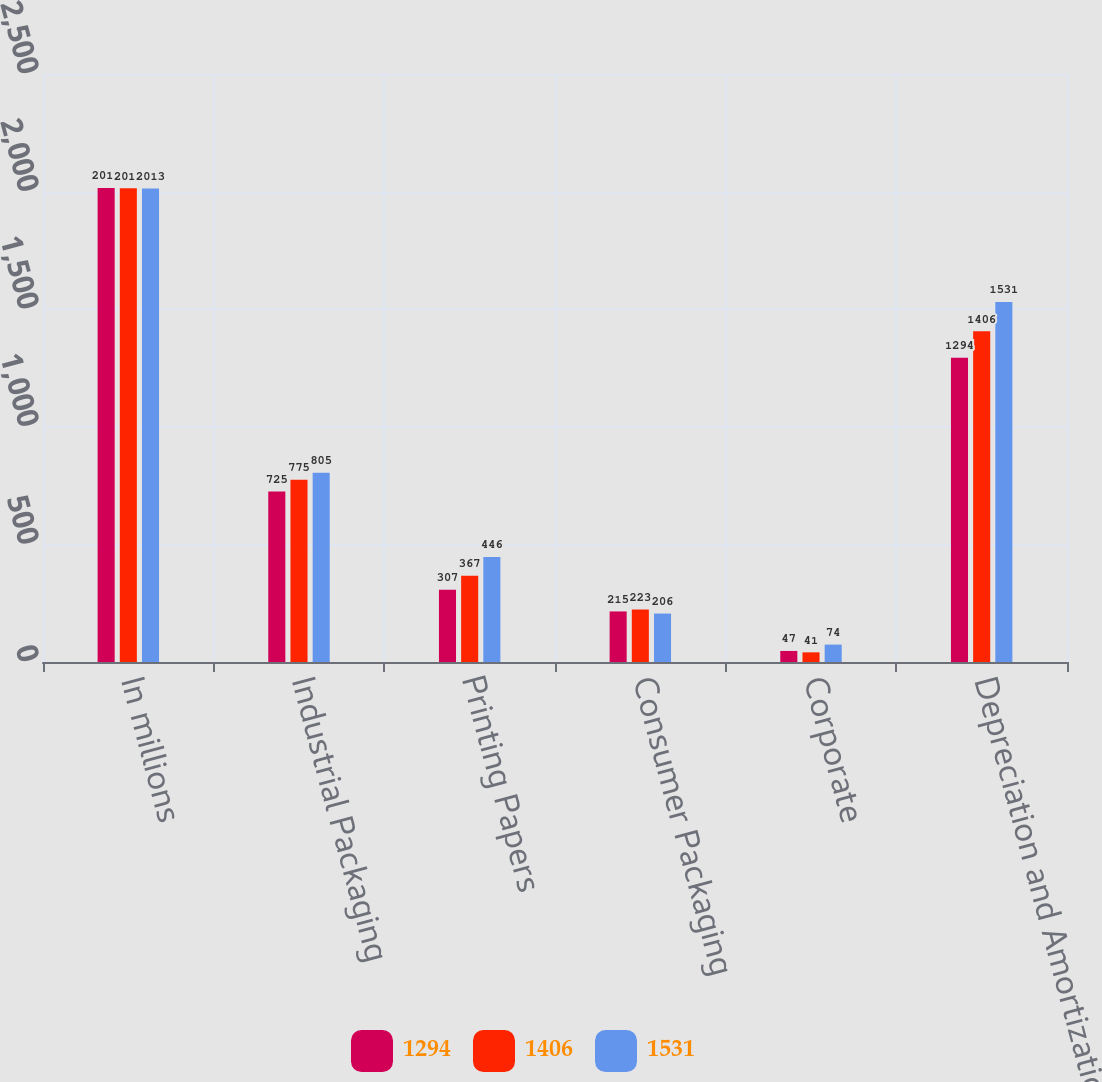Convert chart. <chart><loc_0><loc_0><loc_500><loc_500><stacked_bar_chart><ecel><fcel>In millions<fcel>Industrial Packaging<fcel>Printing Papers<fcel>Consumer Packaging<fcel>Corporate<fcel>Depreciation and Amortization<nl><fcel>1294<fcel>2015<fcel>725<fcel>307<fcel>215<fcel>47<fcel>1294<nl><fcel>1406<fcel>2014<fcel>775<fcel>367<fcel>223<fcel>41<fcel>1406<nl><fcel>1531<fcel>2013<fcel>805<fcel>446<fcel>206<fcel>74<fcel>1531<nl></chart> 